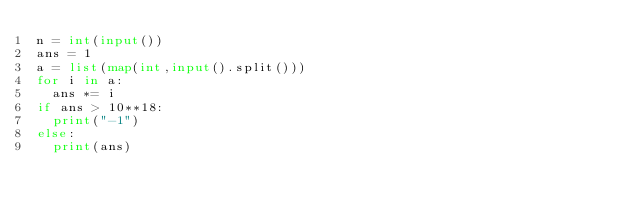<code> <loc_0><loc_0><loc_500><loc_500><_Python_>n = int(input())
ans = 1 
a = list(map(int,input().split()))
for i in a:
  ans *= i
if ans > 10**18:
  print("-1")
else:
  print(ans)</code> 